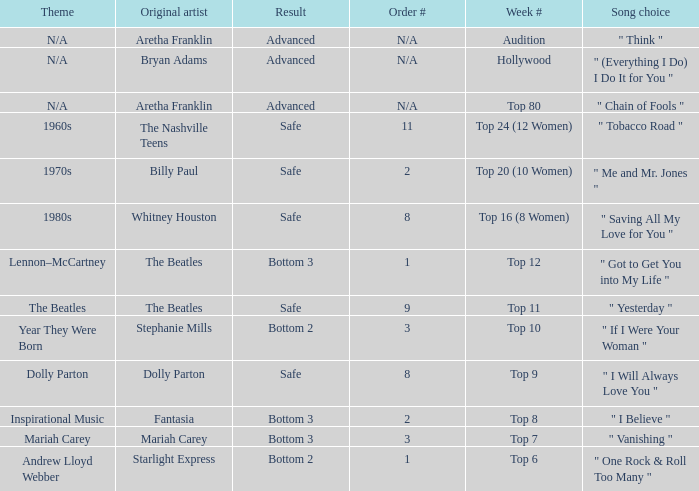Name the order number for the beatles and result is safe 9.0. 